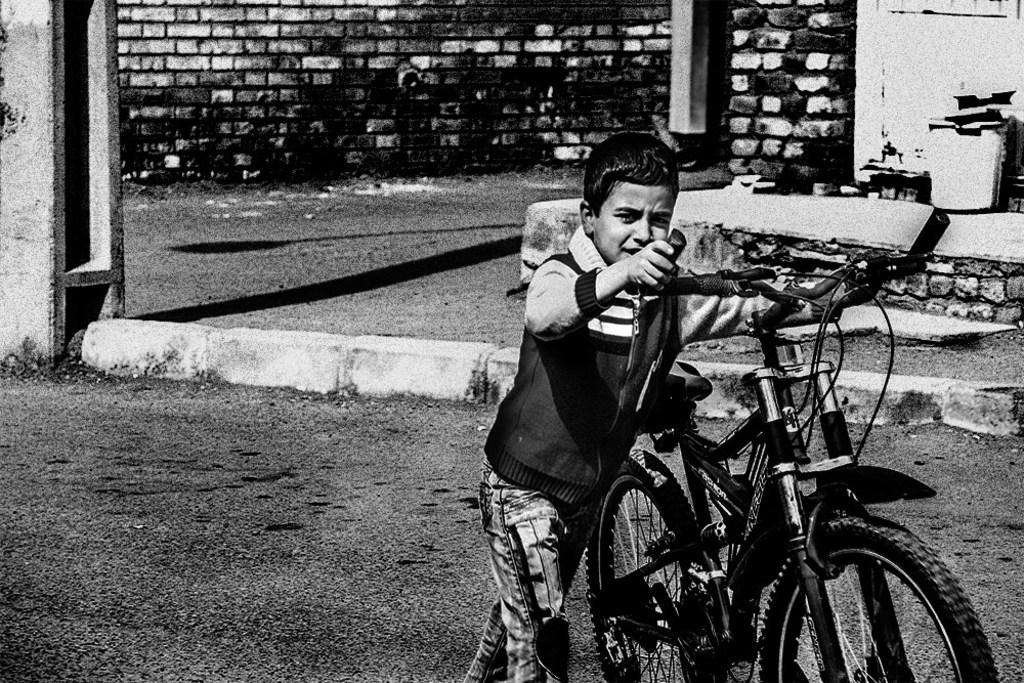What is the color scheme of the image? The image is in black and white. Who is present in the image? There is a boy in the image. What is the boy holding in the image? The boy is holding a bicycle. What is the boy doing in the image? The boy is walking on the road. What can be seen on the floor in the image? There are objects on the floor. What is located on the left side of the image? There is a pillar on the left side of the image. What is visible in the background of the image? There is a brick wall in the background of the image. What type of brush is the boy using to clean the chicken in the image? There is no brush or chicken present in the image. How many bikes are visible in the image? There is only one bicycle visible in the image, as the boy is holding it. 